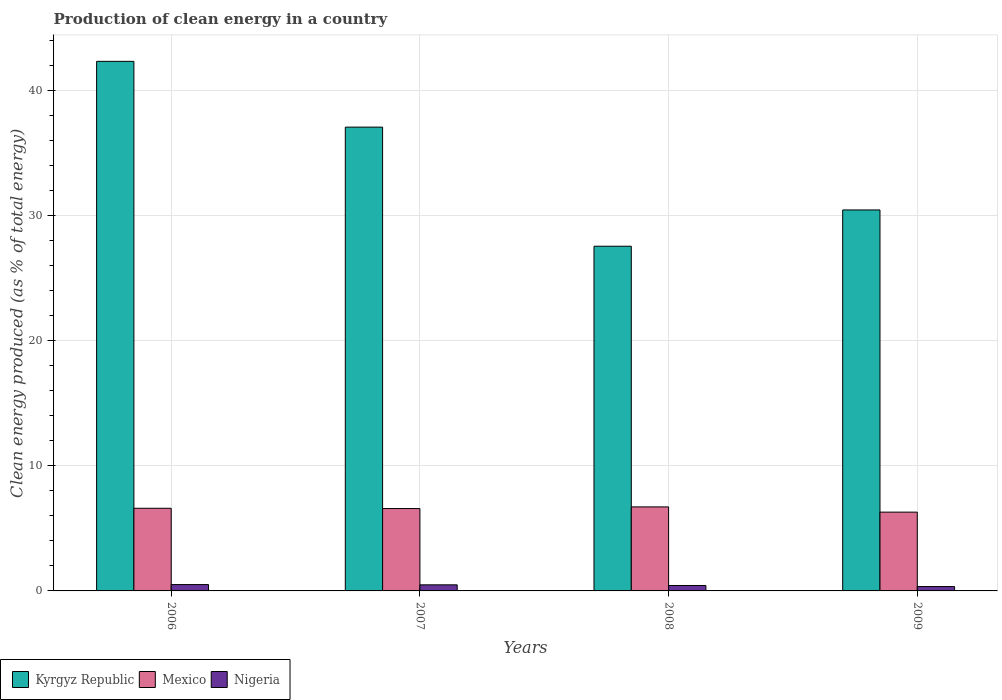How many different coloured bars are there?
Your answer should be compact. 3. How many groups of bars are there?
Keep it short and to the point. 4. Are the number of bars per tick equal to the number of legend labels?
Provide a succinct answer. Yes. How many bars are there on the 1st tick from the left?
Your answer should be compact. 3. What is the percentage of clean energy produced in Mexico in 2007?
Offer a very short reply. 6.59. Across all years, what is the maximum percentage of clean energy produced in Kyrgyz Republic?
Your answer should be very brief. 42.34. Across all years, what is the minimum percentage of clean energy produced in Kyrgyz Republic?
Your answer should be compact. 27.56. In which year was the percentage of clean energy produced in Mexico minimum?
Your answer should be compact. 2009. What is the total percentage of clean energy produced in Mexico in the graph?
Your response must be concise. 26.21. What is the difference between the percentage of clean energy produced in Nigeria in 2006 and that in 2007?
Provide a short and direct response. 0.02. What is the difference between the percentage of clean energy produced in Nigeria in 2008 and the percentage of clean energy produced in Kyrgyz Republic in 2009?
Your answer should be very brief. -30.03. What is the average percentage of clean energy produced in Nigeria per year?
Give a very brief answer. 0.44. In the year 2007, what is the difference between the percentage of clean energy produced in Kyrgyz Republic and percentage of clean energy produced in Mexico?
Your answer should be compact. 30.5. What is the ratio of the percentage of clean energy produced in Nigeria in 2007 to that in 2008?
Keep it short and to the point. 1.12. What is the difference between the highest and the second highest percentage of clean energy produced in Nigeria?
Give a very brief answer. 0.02. What is the difference between the highest and the lowest percentage of clean energy produced in Kyrgyz Republic?
Your answer should be compact. 14.78. In how many years, is the percentage of clean energy produced in Mexico greater than the average percentage of clean energy produced in Mexico taken over all years?
Your answer should be compact. 3. What does the 3rd bar from the left in 2008 represents?
Offer a very short reply. Nigeria. What does the 3rd bar from the right in 2006 represents?
Provide a succinct answer. Kyrgyz Republic. Are all the bars in the graph horizontal?
Provide a succinct answer. No. How many years are there in the graph?
Provide a succinct answer. 4. What is the difference between two consecutive major ticks on the Y-axis?
Offer a terse response. 10. Are the values on the major ticks of Y-axis written in scientific E-notation?
Offer a very short reply. No. Does the graph contain grids?
Make the answer very short. Yes. What is the title of the graph?
Offer a very short reply. Production of clean energy in a country. What is the label or title of the Y-axis?
Offer a very short reply. Clean energy produced (as % of total energy). What is the Clean energy produced (as % of total energy) in Kyrgyz Republic in 2006?
Provide a short and direct response. 42.34. What is the Clean energy produced (as % of total energy) of Mexico in 2006?
Keep it short and to the point. 6.61. What is the Clean energy produced (as % of total energy) of Nigeria in 2006?
Your response must be concise. 0.51. What is the Clean energy produced (as % of total energy) in Kyrgyz Republic in 2007?
Ensure brevity in your answer.  37.08. What is the Clean energy produced (as % of total energy) in Mexico in 2007?
Offer a very short reply. 6.59. What is the Clean energy produced (as % of total energy) of Nigeria in 2007?
Provide a short and direct response. 0.49. What is the Clean energy produced (as % of total energy) in Kyrgyz Republic in 2008?
Keep it short and to the point. 27.56. What is the Clean energy produced (as % of total energy) in Mexico in 2008?
Offer a terse response. 6.72. What is the Clean energy produced (as % of total energy) of Nigeria in 2008?
Give a very brief answer. 0.43. What is the Clean energy produced (as % of total energy) in Kyrgyz Republic in 2009?
Give a very brief answer. 30.46. What is the Clean energy produced (as % of total energy) of Mexico in 2009?
Your answer should be compact. 6.3. What is the Clean energy produced (as % of total energy) of Nigeria in 2009?
Your answer should be very brief. 0.35. Across all years, what is the maximum Clean energy produced (as % of total energy) of Kyrgyz Republic?
Keep it short and to the point. 42.34. Across all years, what is the maximum Clean energy produced (as % of total energy) of Mexico?
Provide a short and direct response. 6.72. Across all years, what is the maximum Clean energy produced (as % of total energy) in Nigeria?
Make the answer very short. 0.51. Across all years, what is the minimum Clean energy produced (as % of total energy) of Kyrgyz Republic?
Your answer should be very brief. 27.56. Across all years, what is the minimum Clean energy produced (as % of total energy) of Mexico?
Provide a succinct answer. 6.3. Across all years, what is the minimum Clean energy produced (as % of total energy) in Nigeria?
Your answer should be very brief. 0.35. What is the total Clean energy produced (as % of total energy) in Kyrgyz Republic in the graph?
Your response must be concise. 137.45. What is the total Clean energy produced (as % of total energy) of Mexico in the graph?
Your answer should be compact. 26.21. What is the total Clean energy produced (as % of total energy) in Nigeria in the graph?
Your answer should be very brief. 1.78. What is the difference between the Clean energy produced (as % of total energy) in Kyrgyz Republic in 2006 and that in 2007?
Keep it short and to the point. 5.26. What is the difference between the Clean energy produced (as % of total energy) of Mexico in 2006 and that in 2007?
Your answer should be compact. 0.02. What is the difference between the Clean energy produced (as % of total energy) of Nigeria in 2006 and that in 2007?
Your answer should be very brief. 0.02. What is the difference between the Clean energy produced (as % of total energy) in Kyrgyz Republic in 2006 and that in 2008?
Keep it short and to the point. 14.78. What is the difference between the Clean energy produced (as % of total energy) of Mexico in 2006 and that in 2008?
Keep it short and to the point. -0.11. What is the difference between the Clean energy produced (as % of total energy) in Nigeria in 2006 and that in 2008?
Make the answer very short. 0.07. What is the difference between the Clean energy produced (as % of total energy) of Kyrgyz Republic in 2006 and that in 2009?
Keep it short and to the point. 11.88. What is the difference between the Clean energy produced (as % of total energy) of Mexico in 2006 and that in 2009?
Keep it short and to the point. 0.31. What is the difference between the Clean energy produced (as % of total energy) in Nigeria in 2006 and that in 2009?
Give a very brief answer. 0.16. What is the difference between the Clean energy produced (as % of total energy) of Kyrgyz Republic in 2007 and that in 2008?
Keep it short and to the point. 9.52. What is the difference between the Clean energy produced (as % of total energy) of Mexico in 2007 and that in 2008?
Your response must be concise. -0.13. What is the difference between the Clean energy produced (as % of total energy) in Nigeria in 2007 and that in 2008?
Your answer should be very brief. 0.05. What is the difference between the Clean energy produced (as % of total energy) of Kyrgyz Republic in 2007 and that in 2009?
Keep it short and to the point. 6.62. What is the difference between the Clean energy produced (as % of total energy) of Mexico in 2007 and that in 2009?
Give a very brief answer. 0.29. What is the difference between the Clean energy produced (as % of total energy) of Nigeria in 2007 and that in 2009?
Your answer should be compact. 0.14. What is the difference between the Clean energy produced (as % of total energy) in Kyrgyz Republic in 2008 and that in 2009?
Ensure brevity in your answer.  -2.9. What is the difference between the Clean energy produced (as % of total energy) of Mexico in 2008 and that in 2009?
Ensure brevity in your answer.  0.42. What is the difference between the Clean energy produced (as % of total energy) in Nigeria in 2008 and that in 2009?
Your answer should be very brief. 0.09. What is the difference between the Clean energy produced (as % of total energy) in Kyrgyz Republic in 2006 and the Clean energy produced (as % of total energy) in Mexico in 2007?
Make the answer very short. 35.76. What is the difference between the Clean energy produced (as % of total energy) of Kyrgyz Republic in 2006 and the Clean energy produced (as % of total energy) of Nigeria in 2007?
Ensure brevity in your answer.  41.86. What is the difference between the Clean energy produced (as % of total energy) of Mexico in 2006 and the Clean energy produced (as % of total energy) of Nigeria in 2007?
Offer a very short reply. 6.12. What is the difference between the Clean energy produced (as % of total energy) in Kyrgyz Republic in 2006 and the Clean energy produced (as % of total energy) in Mexico in 2008?
Offer a very short reply. 35.63. What is the difference between the Clean energy produced (as % of total energy) in Kyrgyz Republic in 2006 and the Clean energy produced (as % of total energy) in Nigeria in 2008?
Offer a terse response. 41.91. What is the difference between the Clean energy produced (as % of total energy) of Mexico in 2006 and the Clean energy produced (as % of total energy) of Nigeria in 2008?
Provide a short and direct response. 6.17. What is the difference between the Clean energy produced (as % of total energy) in Kyrgyz Republic in 2006 and the Clean energy produced (as % of total energy) in Mexico in 2009?
Make the answer very short. 36.04. What is the difference between the Clean energy produced (as % of total energy) of Kyrgyz Republic in 2006 and the Clean energy produced (as % of total energy) of Nigeria in 2009?
Your response must be concise. 41.99. What is the difference between the Clean energy produced (as % of total energy) in Mexico in 2006 and the Clean energy produced (as % of total energy) in Nigeria in 2009?
Provide a short and direct response. 6.26. What is the difference between the Clean energy produced (as % of total energy) in Kyrgyz Republic in 2007 and the Clean energy produced (as % of total energy) in Mexico in 2008?
Your answer should be compact. 30.37. What is the difference between the Clean energy produced (as % of total energy) of Kyrgyz Republic in 2007 and the Clean energy produced (as % of total energy) of Nigeria in 2008?
Keep it short and to the point. 36.65. What is the difference between the Clean energy produced (as % of total energy) of Mexico in 2007 and the Clean energy produced (as % of total energy) of Nigeria in 2008?
Offer a terse response. 6.15. What is the difference between the Clean energy produced (as % of total energy) of Kyrgyz Republic in 2007 and the Clean energy produced (as % of total energy) of Mexico in 2009?
Keep it short and to the point. 30.78. What is the difference between the Clean energy produced (as % of total energy) in Kyrgyz Republic in 2007 and the Clean energy produced (as % of total energy) in Nigeria in 2009?
Offer a very short reply. 36.73. What is the difference between the Clean energy produced (as % of total energy) of Mexico in 2007 and the Clean energy produced (as % of total energy) of Nigeria in 2009?
Ensure brevity in your answer.  6.24. What is the difference between the Clean energy produced (as % of total energy) of Kyrgyz Republic in 2008 and the Clean energy produced (as % of total energy) of Mexico in 2009?
Your answer should be compact. 21.26. What is the difference between the Clean energy produced (as % of total energy) in Kyrgyz Republic in 2008 and the Clean energy produced (as % of total energy) in Nigeria in 2009?
Your answer should be compact. 27.21. What is the difference between the Clean energy produced (as % of total energy) of Mexico in 2008 and the Clean energy produced (as % of total energy) of Nigeria in 2009?
Provide a short and direct response. 6.37. What is the average Clean energy produced (as % of total energy) of Kyrgyz Republic per year?
Make the answer very short. 34.36. What is the average Clean energy produced (as % of total energy) of Mexico per year?
Provide a short and direct response. 6.55. What is the average Clean energy produced (as % of total energy) of Nigeria per year?
Your response must be concise. 0.44. In the year 2006, what is the difference between the Clean energy produced (as % of total energy) of Kyrgyz Republic and Clean energy produced (as % of total energy) of Mexico?
Ensure brevity in your answer.  35.73. In the year 2006, what is the difference between the Clean energy produced (as % of total energy) of Kyrgyz Republic and Clean energy produced (as % of total energy) of Nigeria?
Provide a short and direct response. 41.84. In the year 2006, what is the difference between the Clean energy produced (as % of total energy) of Mexico and Clean energy produced (as % of total energy) of Nigeria?
Your response must be concise. 6.1. In the year 2007, what is the difference between the Clean energy produced (as % of total energy) of Kyrgyz Republic and Clean energy produced (as % of total energy) of Mexico?
Your response must be concise. 30.5. In the year 2007, what is the difference between the Clean energy produced (as % of total energy) of Kyrgyz Republic and Clean energy produced (as % of total energy) of Nigeria?
Provide a short and direct response. 36.6. In the year 2007, what is the difference between the Clean energy produced (as % of total energy) of Mexico and Clean energy produced (as % of total energy) of Nigeria?
Your answer should be very brief. 6.1. In the year 2008, what is the difference between the Clean energy produced (as % of total energy) of Kyrgyz Republic and Clean energy produced (as % of total energy) of Mexico?
Your response must be concise. 20.84. In the year 2008, what is the difference between the Clean energy produced (as % of total energy) of Kyrgyz Republic and Clean energy produced (as % of total energy) of Nigeria?
Your response must be concise. 27.13. In the year 2008, what is the difference between the Clean energy produced (as % of total energy) of Mexico and Clean energy produced (as % of total energy) of Nigeria?
Give a very brief answer. 6.28. In the year 2009, what is the difference between the Clean energy produced (as % of total energy) in Kyrgyz Republic and Clean energy produced (as % of total energy) in Mexico?
Your answer should be compact. 24.16. In the year 2009, what is the difference between the Clean energy produced (as % of total energy) in Kyrgyz Republic and Clean energy produced (as % of total energy) in Nigeria?
Offer a very short reply. 30.11. In the year 2009, what is the difference between the Clean energy produced (as % of total energy) in Mexico and Clean energy produced (as % of total energy) in Nigeria?
Your answer should be compact. 5.95. What is the ratio of the Clean energy produced (as % of total energy) in Kyrgyz Republic in 2006 to that in 2007?
Ensure brevity in your answer.  1.14. What is the ratio of the Clean energy produced (as % of total energy) in Mexico in 2006 to that in 2007?
Ensure brevity in your answer.  1. What is the ratio of the Clean energy produced (as % of total energy) of Nigeria in 2006 to that in 2007?
Make the answer very short. 1.04. What is the ratio of the Clean energy produced (as % of total energy) in Kyrgyz Republic in 2006 to that in 2008?
Keep it short and to the point. 1.54. What is the ratio of the Clean energy produced (as % of total energy) in Mexico in 2006 to that in 2008?
Give a very brief answer. 0.98. What is the ratio of the Clean energy produced (as % of total energy) of Nigeria in 2006 to that in 2008?
Keep it short and to the point. 1.17. What is the ratio of the Clean energy produced (as % of total energy) of Kyrgyz Republic in 2006 to that in 2009?
Keep it short and to the point. 1.39. What is the ratio of the Clean energy produced (as % of total energy) of Mexico in 2006 to that in 2009?
Ensure brevity in your answer.  1.05. What is the ratio of the Clean energy produced (as % of total energy) of Nigeria in 2006 to that in 2009?
Offer a terse response. 1.45. What is the ratio of the Clean energy produced (as % of total energy) of Kyrgyz Republic in 2007 to that in 2008?
Your answer should be compact. 1.35. What is the ratio of the Clean energy produced (as % of total energy) in Mexico in 2007 to that in 2008?
Keep it short and to the point. 0.98. What is the ratio of the Clean energy produced (as % of total energy) in Nigeria in 2007 to that in 2008?
Your answer should be compact. 1.12. What is the ratio of the Clean energy produced (as % of total energy) in Kyrgyz Republic in 2007 to that in 2009?
Make the answer very short. 1.22. What is the ratio of the Clean energy produced (as % of total energy) of Mexico in 2007 to that in 2009?
Your answer should be compact. 1.05. What is the ratio of the Clean energy produced (as % of total energy) in Nigeria in 2007 to that in 2009?
Your answer should be very brief. 1.39. What is the ratio of the Clean energy produced (as % of total energy) of Kyrgyz Republic in 2008 to that in 2009?
Keep it short and to the point. 0.9. What is the ratio of the Clean energy produced (as % of total energy) in Mexico in 2008 to that in 2009?
Your answer should be compact. 1.07. What is the ratio of the Clean energy produced (as % of total energy) of Nigeria in 2008 to that in 2009?
Your answer should be very brief. 1.24. What is the difference between the highest and the second highest Clean energy produced (as % of total energy) in Kyrgyz Republic?
Your answer should be very brief. 5.26. What is the difference between the highest and the second highest Clean energy produced (as % of total energy) of Mexico?
Your answer should be compact. 0.11. What is the difference between the highest and the second highest Clean energy produced (as % of total energy) of Nigeria?
Your response must be concise. 0.02. What is the difference between the highest and the lowest Clean energy produced (as % of total energy) of Kyrgyz Republic?
Ensure brevity in your answer.  14.78. What is the difference between the highest and the lowest Clean energy produced (as % of total energy) in Mexico?
Give a very brief answer. 0.42. What is the difference between the highest and the lowest Clean energy produced (as % of total energy) in Nigeria?
Your answer should be compact. 0.16. 